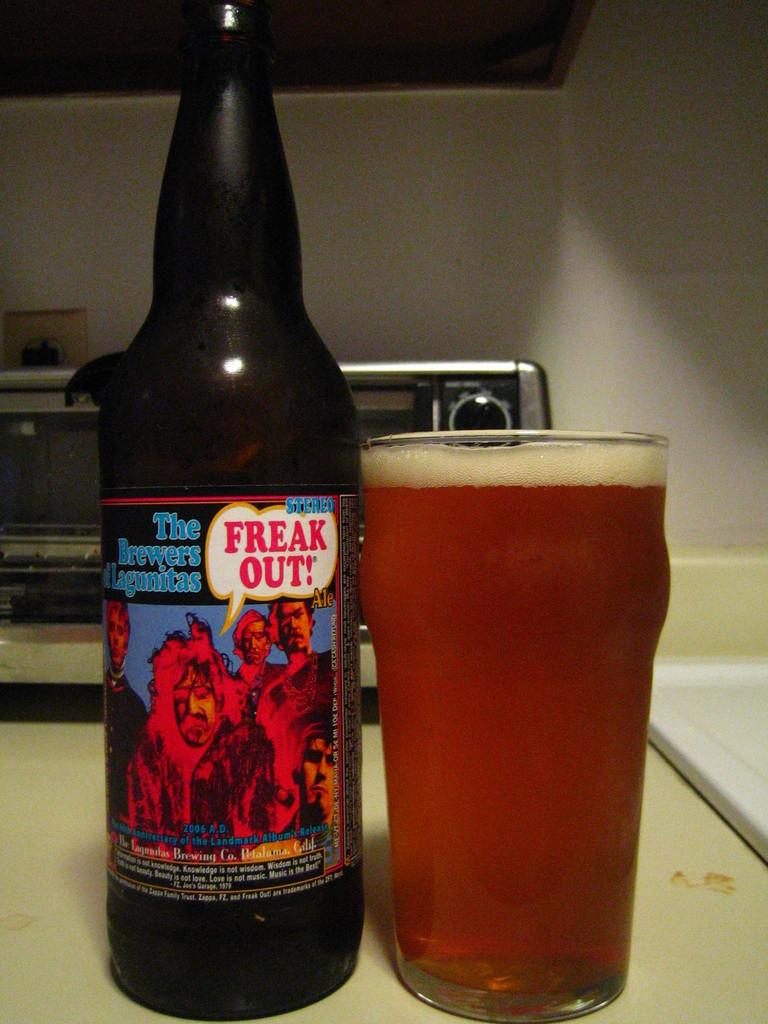<image>
Relay a brief, clear account of the picture shown. A bottle of the brewers Lagunitas next to a full glass of it. 